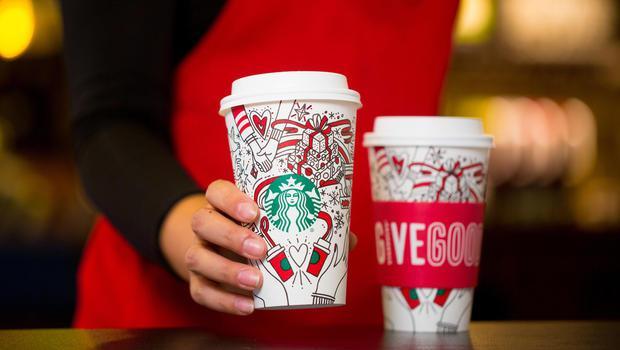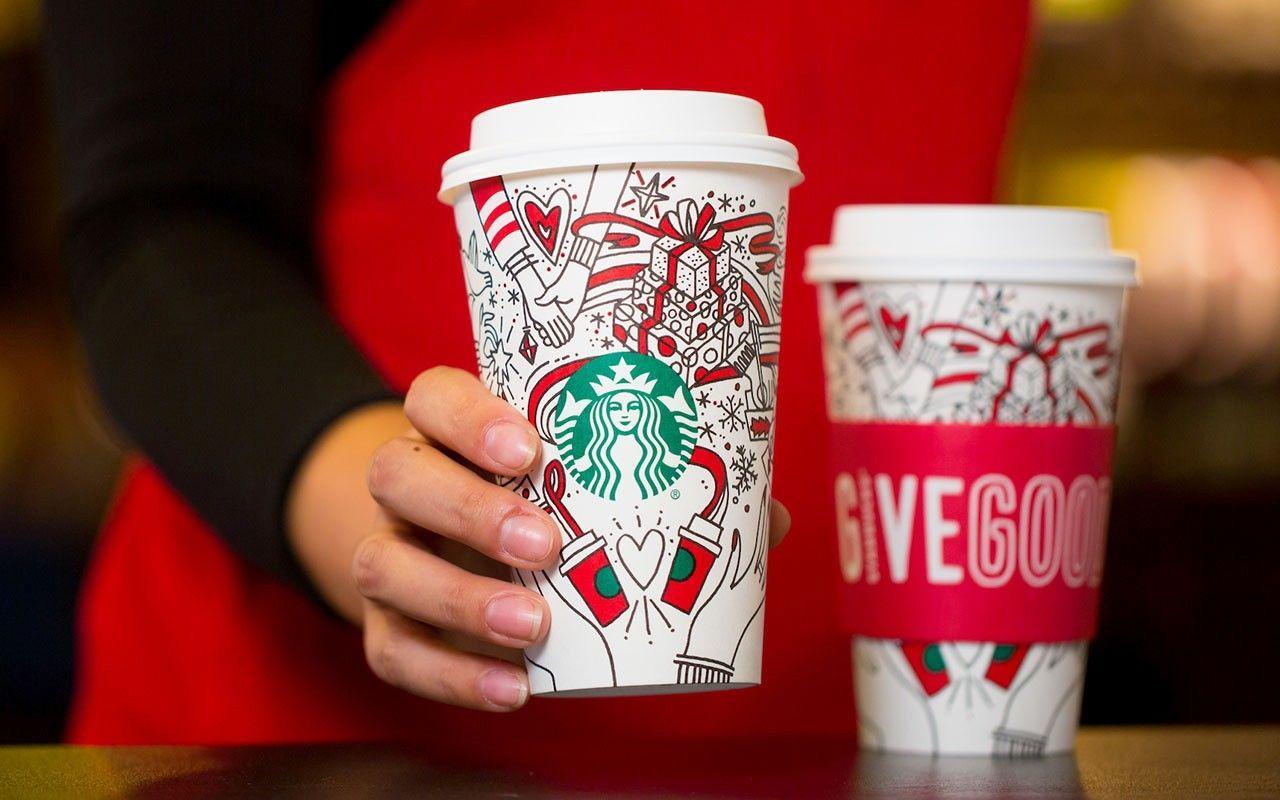The first image is the image on the left, the second image is the image on the right. Considering the images on both sides, is "In both images a person is holding a cup in their hand." valid? Answer yes or no. Yes. 